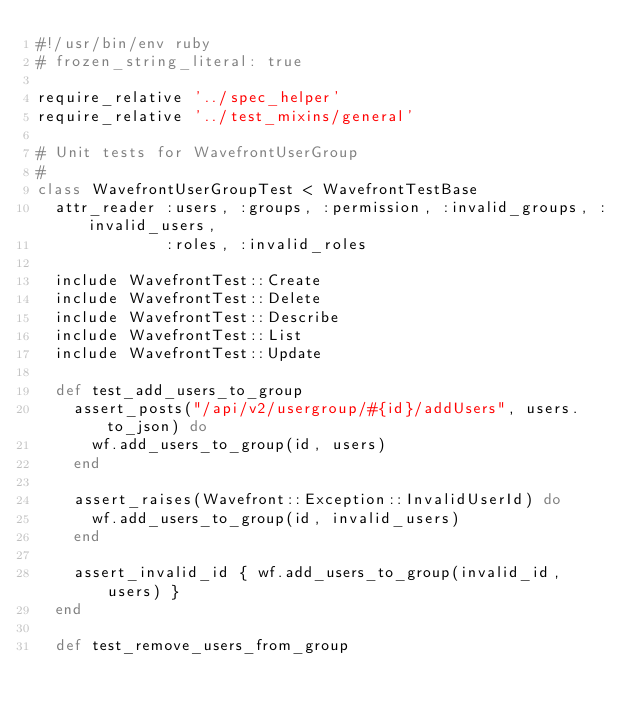Convert code to text. <code><loc_0><loc_0><loc_500><loc_500><_Ruby_>#!/usr/bin/env ruby
# frozen_string_literal: true

require_relative '../spec_helper'
require_relative '../test_mixins/general'

# Unit tests for WavefrontUserGroup
#
class WavefrontUserGroupTest < WavefrontTestBase
  attr_reader :users, :groups, :permission, :invalid_groups, :invalid_users,
              :roles, :invalid_roles

  include WavefrontTest::Create
  include WavefrontTest::Delete
  include WavefrontTest::Describe
  include WavefrontTest::List
  include WavefrontTest::Update

  def test_add_users_to_group
    assert_posts("/api/v2/usergroup/#{id}/addUsers", users.to_json) do
      wf.add_users_to_group(id, users)
    end

    assert_raises(Wavefront::Exception::InvalidUserId) do
      wf.add_users_to_group(id, invalid_users)
    end

    assert_invalid_id { wf.add_users_to_group(invalid_id, users) }
  end

  def test_remove_users_from_group</code> 